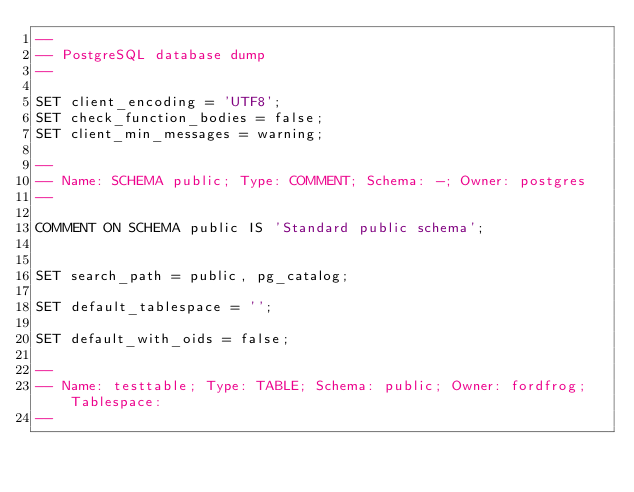<code> <loc_0><loc_0><loc_500><loc_500><_SQL_>--
-- PostgreSQL database dump
--

SET client_encoding = 'UTF8';
SET check_function_bodies = false;
SET client_min_messages = warning;

--
-- Name: SCHEMA public; Type: COMMENT; Schema: -; Owner: postgres
--

COMMENT ON SCHEMA public IS 'Standard public schema';


SET search_path = public, pg_catalog;

SET default_tablespace = '';

SET default_with_oids = false;

--
-- Name: testtable; Type: TABLE; Schema: public; Owner: fordfrog; Tablespace: 
--
</code> 